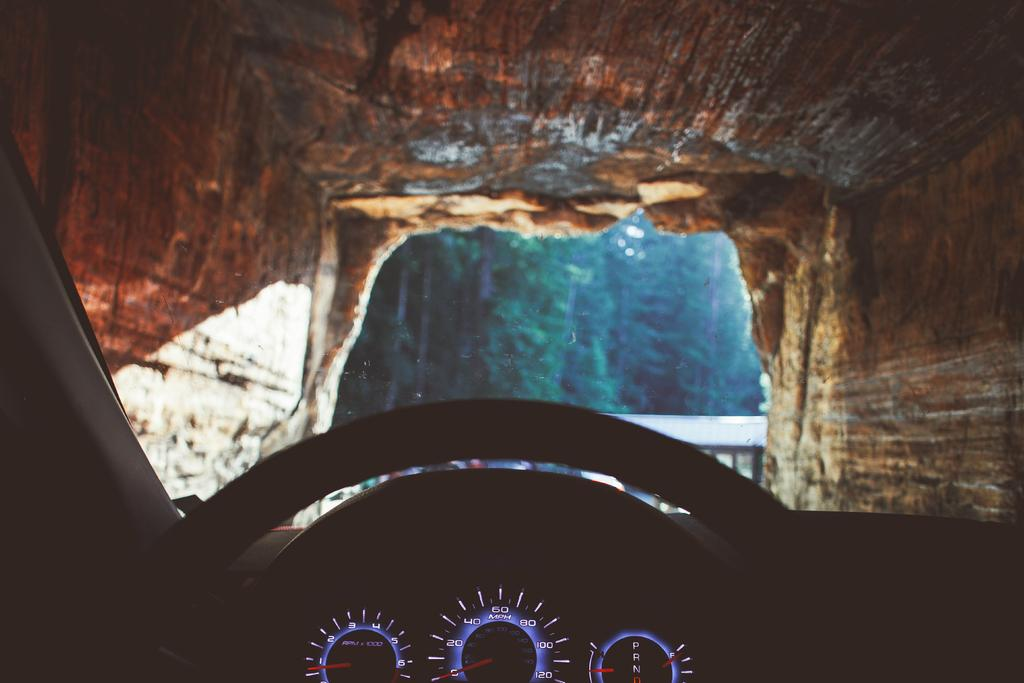What is the main subject of the image? The main subject of the image is a car steering. What is located in the background of the image? There are trees in the background of the image. What other feature can be seen in the image? There is a cave in the image. How many chickens are visible in the image? There are no chickens present in the image. What is the fifth element in the image? The image only has three elements mentioned in the facts: a car steering, a cave, and trees. There is no fifth element. 